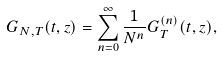Convert formula to latex. <formula><loc_0><loc_0><loc_500><loc_500>G _ { N , T } ( t , z ) = \sum _ { n = 0 } ^ { \infty } \frac { 1 } { N ^ { n } } G _ { T } ^ { ( n ) } ( t , z ) ,</formula> 